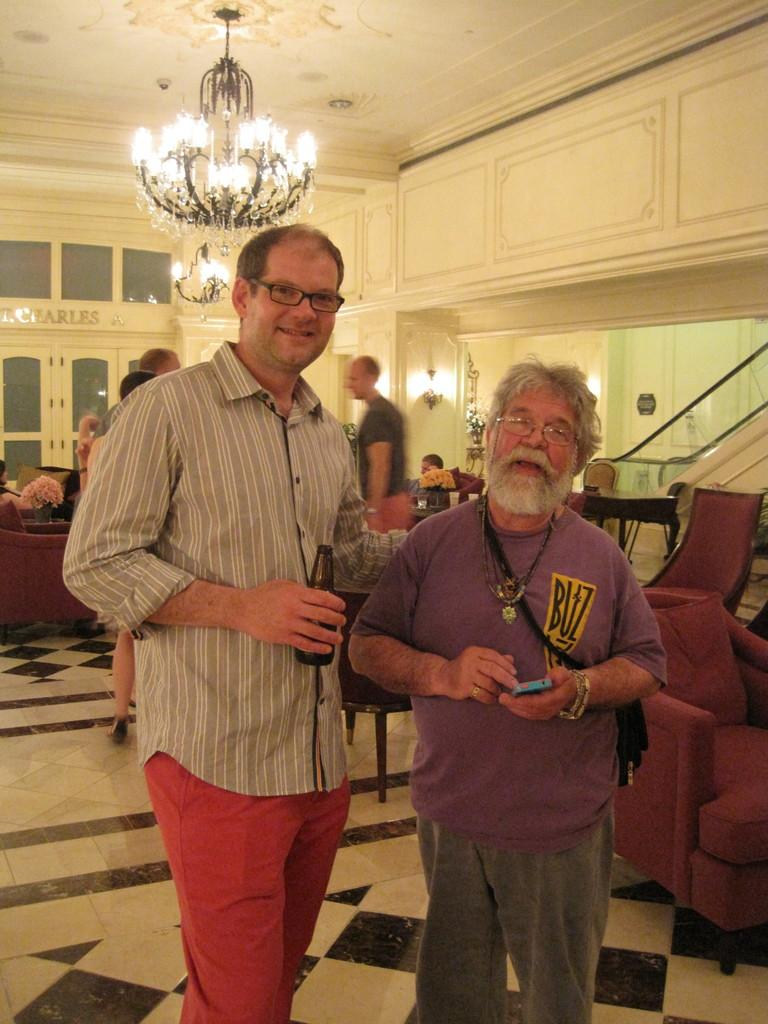How many people are in the image? There are two persons standing in the image. What objects are present for sitting? Chairs are visible in the image. Can you describe the background of the image? There is a wall in the background of the image. What is hanging from the ceiling in the image? There is a chandelier at the top of the image. What type of bead is being used to decorate the throat of the person in the image? There is no bead or any reference to a throat in the image; it features two persons standing with chairs and a chandelier in the background. 